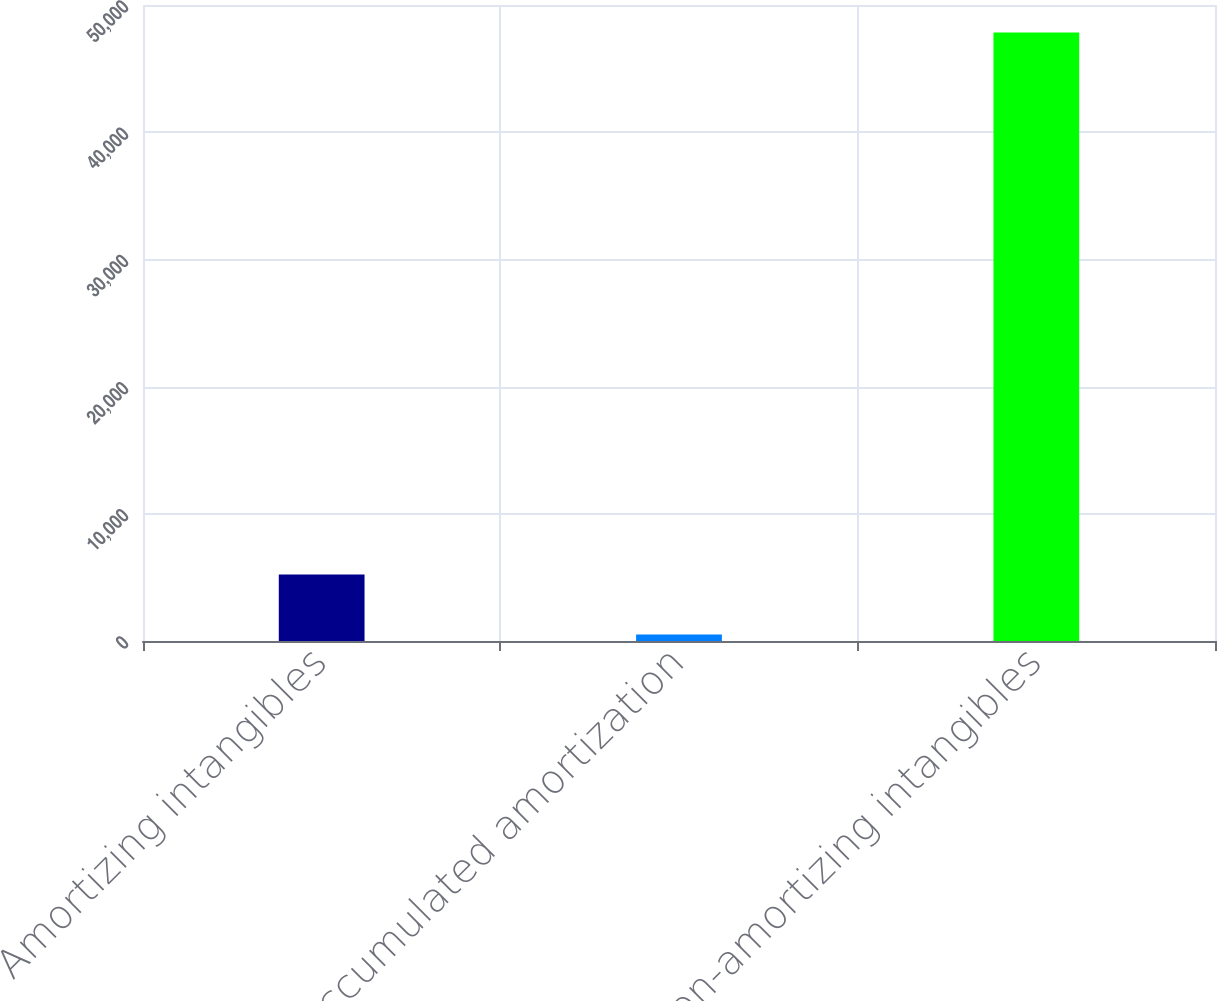<chart> <loc_0><loc_0><loc_500><loc_500><bar_chart><fcel>Amortizing intangibles<fcel>Accumulated amortization<fcel>Non-amortizing intangibles<nl><fcel>5237.7<fcel>504<fcel>47841<nl></chart> 